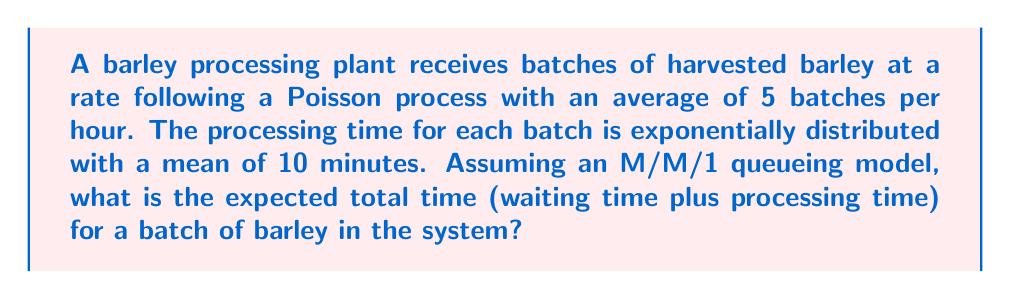Solve this math problem. Let's approach this step-by-step using queueing theory:

1. Identify the model parameters:
   - Arrival rate: $\lambda = 5$ batches/hour = $\frac{5}{60}$ batches/minute
   - Service rate: $\mu = \frac{1}{10}$ batches/minute (as mean processing time is 10 minutes)

2. Calculate the utilization factor $\rho$:
   $$\rho = \frac{\lambda}{\mu} = \frac{5/60}{1/10} = \frac{5}{6} \approx 0.833$$

3. For an M/M/1 queue, the expected total time in the system (W) is given by:
   $$W = \frac{1}{\mu - \lambda}$$

4. Substitute the values:
   $$W = \frac{1}{(1/10) - (5/60)} = \frac{1}{0.1 - 0.0833} = \frac{1}{0.0167}$$

5. Simplify:
   $$W = 60 \text{ minutes}$$

Therefore, the expected total time for a batch of barley in the system is 60 minutes.
Answer: 60 minutes 